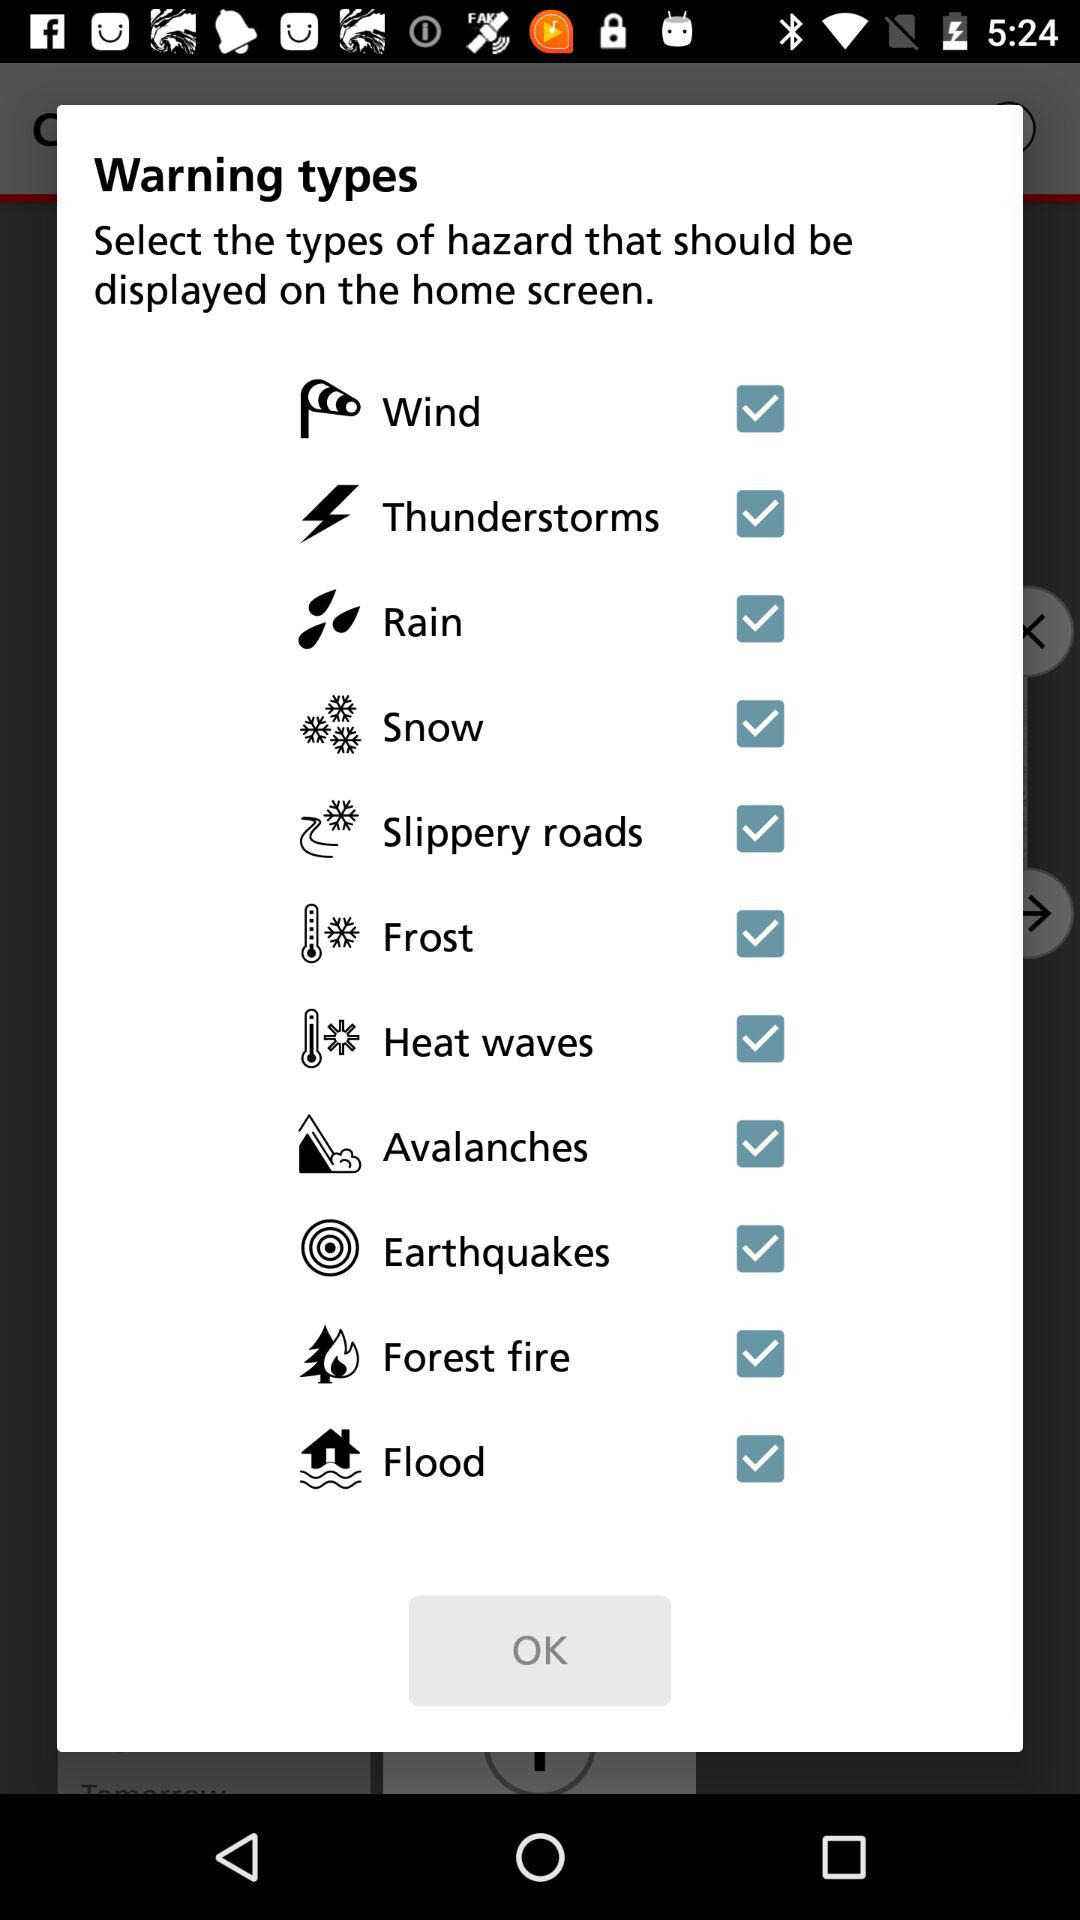Is Rain selected or not?
When the provided information is insufficient, respond with <no answer>. <no answer> 